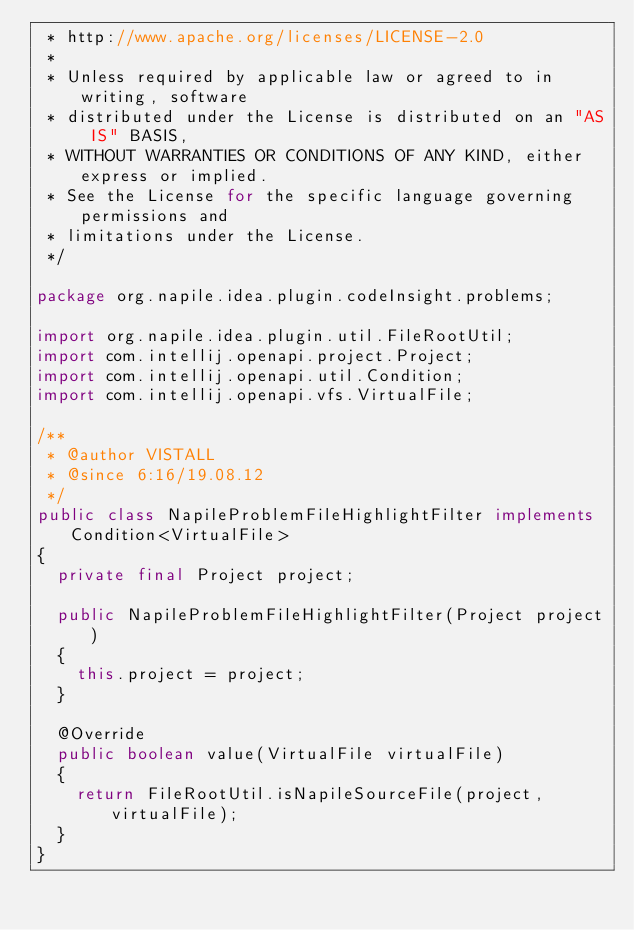<code> <loc_0><loc_0><loc_500><loc_500><_Java_> * http://www.apache.org/licenses/LICENSE-2.0
 *
 * Unless required by applicable law or agreed to in writing, software
 * distributed under the License is distributed on an "AS IS" BASIS,
 * WITHOUT WARRANTIES OR CONDITIONS OF ANY KIND, either express or implied.
 * See the License for the specific language governing permissions and
 * limitations under the License.
 */

package org.napile.idea.plugin.codeInsight.problems;

import org.napile.idea.plugin.util.FileRootUtil;
import com.intellij.openapi.project.Project;
import com.intellij.openapi.util.Condition;
import com.intellij.openapi.vfs.VirtualFile;

/**
 * @author VISTALL
 * @since 6:16/19.08.12
 */
public class NapileProblemFileHighlightFilter implements Condition<VirtualFile>
{
	private final Project project;

	public NapileProblemFileHighlightFilter(Project project)
	{
		this.project = project;
	}

	@Override
	public boolean value(VirtualFile virtualFile)
	{
		return FileRootUtil.isNapileSourceFile(project, virtualFile);
	}
}
</code> 